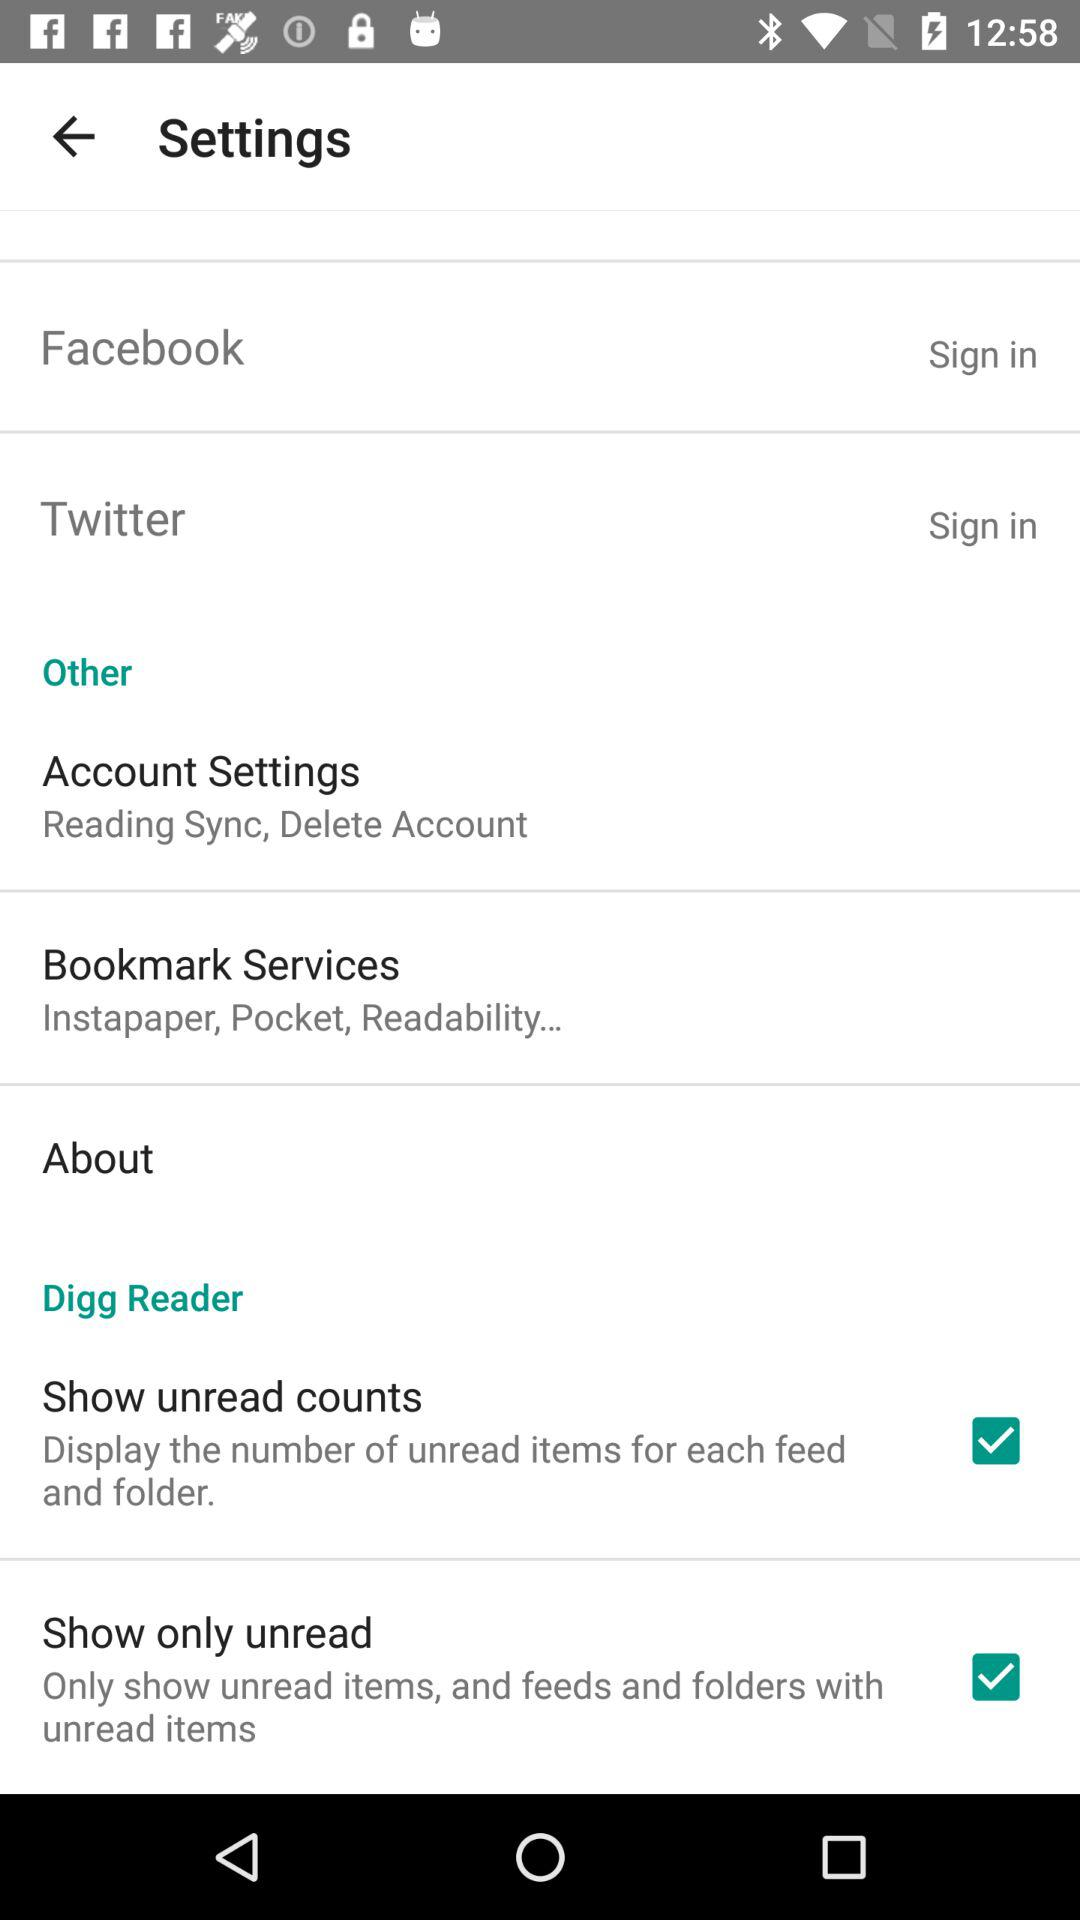What are the options in "Bookmark Services"? The options in "Bookmark Services" are "Instapaper", "Pocket", "Readability...". 